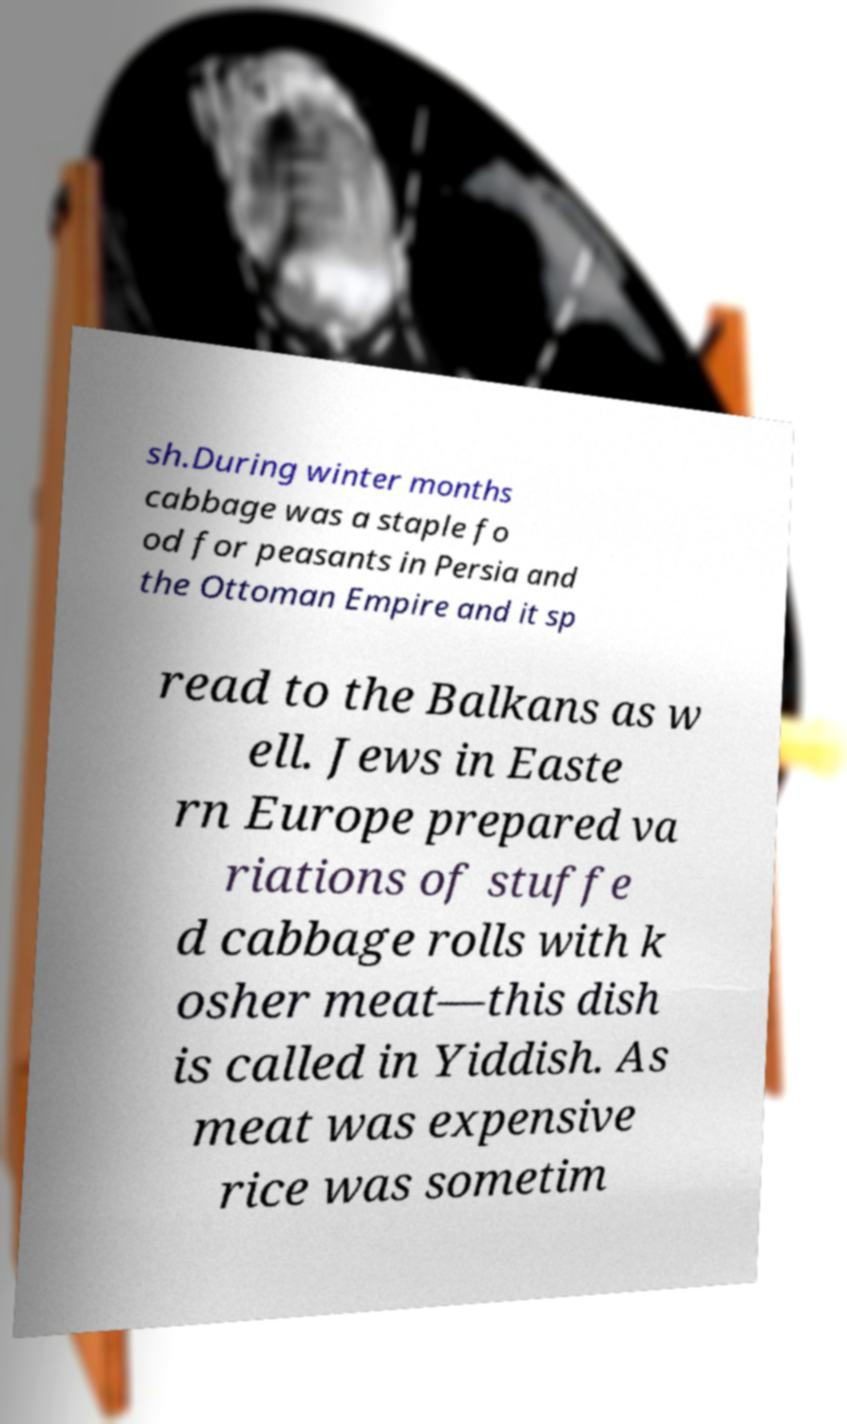What messages or text are displayed in this image? I need them in a readable, typed format. sh.During winter months cabbage was a staple fo od for peasants in Persia and the Ottoman Empire and it sp read to the Balkans as w ell. Jews in Easte rn Europe prepared va riations of stuffe d cabbage rolls with k osher meat—this dish is called in Yiddish. As meat was expensive rice was sometim 